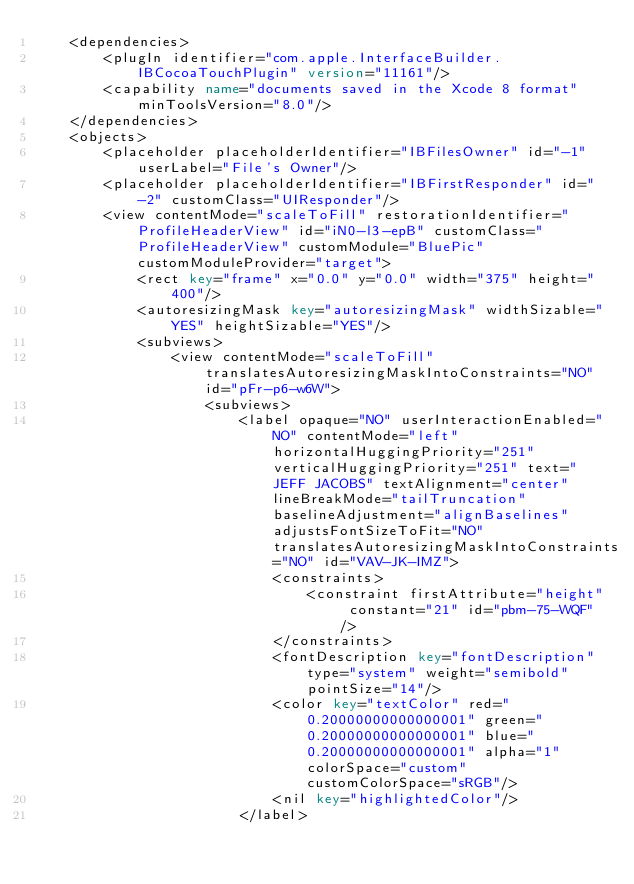<code> <loc_0><loc_0><loc_500><loc_500><_XML_>    <dependencies>
        <plugIn identifier="com.apple.InterfaceBuilder.IBCocoaTouchPlugin" version="11161"/>
        <capability name="documents saved in the Xcode 8 format" minToolsVersion="8.0"/>
    </dependencies>
    <objects>
        <placeholder placeholderIdentifier="IBFilesOwner" id="-1" userLabel="File's Owner"/>
        <placeholder placeholderIdentifier="IBFirstResponder" id="-2" customClass="UIResponder"/>
        <view contentMode="scaleToFill" restorationIdentifier="ProfileHeaderView" id="iN0-l3-epB" customClass="ProfileHeaderView" customModule="BluePic" customModuleProvider="target">
            <rect key="frame" x="0.0" y="0.0" width="375" height="400"/>
            <autoresizingMask key="autoresizingMask" widthSizable="YES" heightSizable="YES"/>
            <subviews>
                <view contentMode="scaleToFill" translatesAutoresizingMaskIntoConstraints="NO" id="pFr-p6-w6W">
                    <subviews>
                        <label opaque="NO" userInteractionEnabled="NO" contentMode="left" horizontalHuggingPriority="251" verticalHuggingPriority="251" text="JEFF JACOBS" textAlignment="center" lineBreakMode="tailTruncation" baselineAdjustment="alignBaselines" adjustsFontSizeToFit="NO" translatesAutoresizingMaskIntoConstraints="NO" id="VAV-JK-IMZ">
                            <constraints>
                                <constraint firstAttribute="height" constant="21" id="pbm-75-WQF"/>
                            </constraints>
                            <fontDescription key="fontDescription" type="system" weight="semibold" pointSize="14"/>
                            <color key="textColor" red="0.20000000000000001" green="0.20000000000000001" blue="0.20000000000000001" alpha="1" colorSpace="custom" customColorSpace="sRGB"/>
                            <nil key="highlightedColor"/>
                        </label></code> 